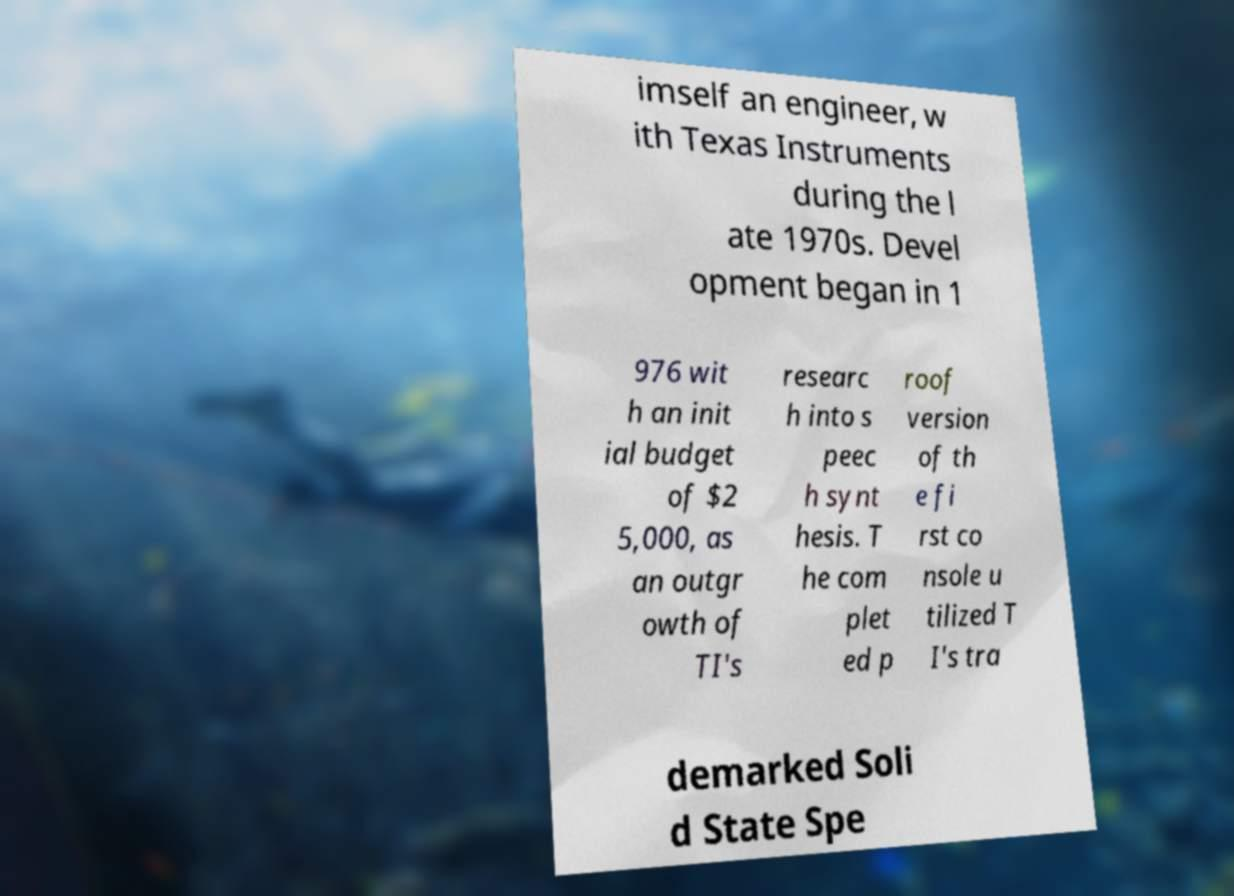Please read and relay the text visible in this image. What does it say? imself an engineer, w ith Texas Instruments during the l ate 1970s. Devel opment began in 1 976 wit h an init ial budget of $2 5,000, as an outgr owth of TI's researc h into s peec h synt hesis. T he com plet ed p roof version of th e fi rst co nsole u tilized T I's tra demarked Soli d State Spe 